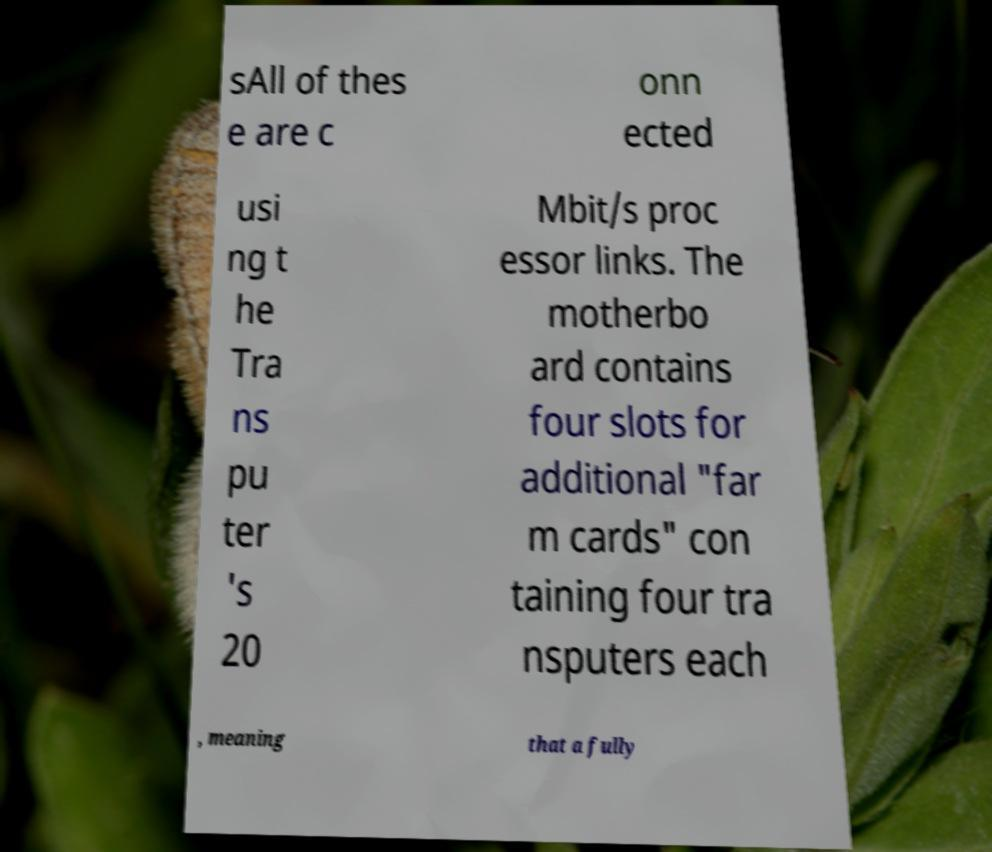I need the written content from this picture converted into text. Can you do that? sAll of thes e are c onn ected usi ng t he Tra ns pu ter 's 20 Mbit/s proc essor links. The motherbo ard contains four slots for additional "far m cards" con taining four tra nsputers each , meaning that a fully 